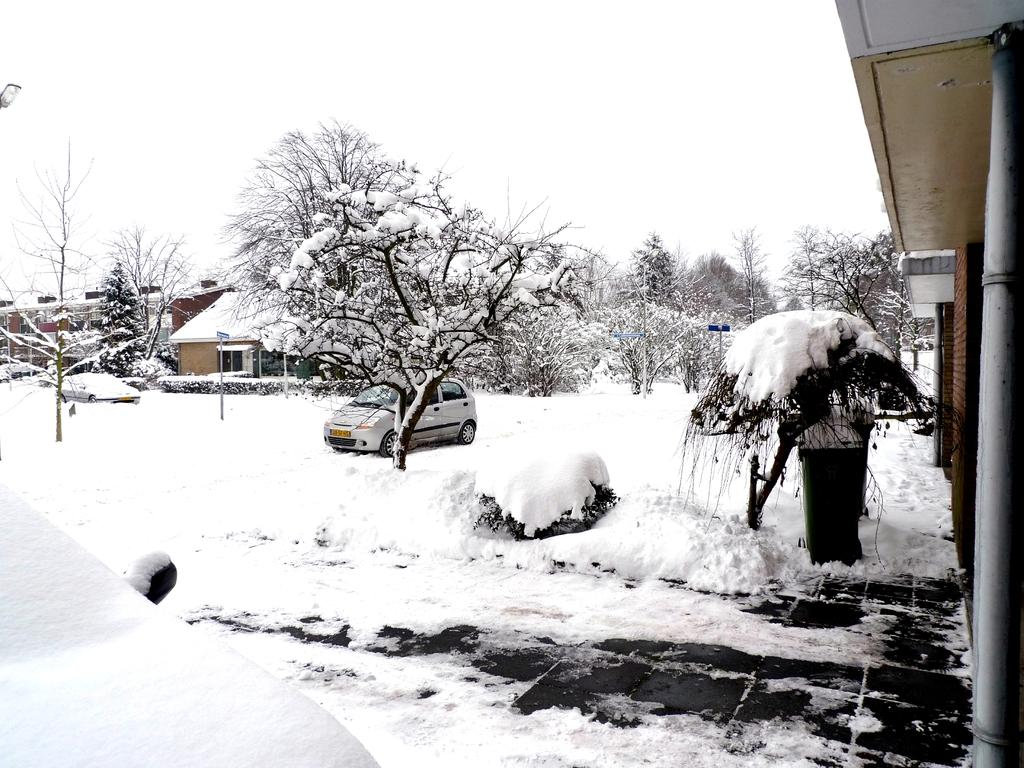What is the main subject of the image? The main subject of the image is a car. What other objects or features can be seen in the image? Trees and a house are present in the image. What is the setting of the image? The car, trees, and house are on a snowy landscape. What is visible at the top of the image? The sky is visible at the top of the image. How many quarters can be seen in the image? There are no quarters present in the image. Are there any planes visible in the image? There are no planes visible in the image. 